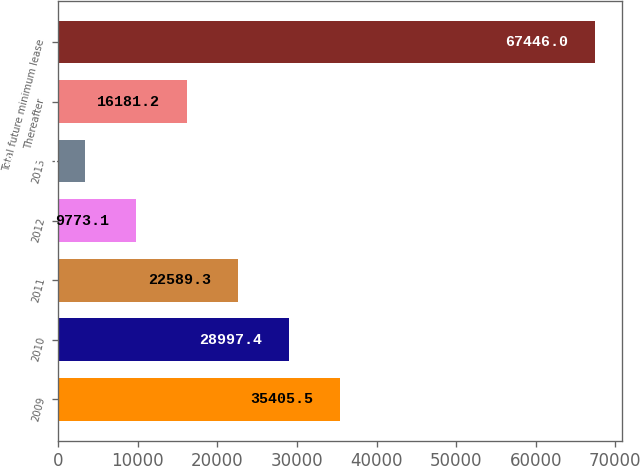Convert chart to OTSL. <chart><loc_0><loc_0><loc_500><loc_500><bar_chart><fcel>2009<fcel>2010<fcel>2011<fcel>2012<fcel>2013<fcel>Thereafter<fcel>Total future minimum lease<nl><fcel>35405.5<fcel>28997.4<fcel>22589.3<fcel>9773.1<fcel>3365<fcel>16181.2<fcel>67446<nl></chart> 